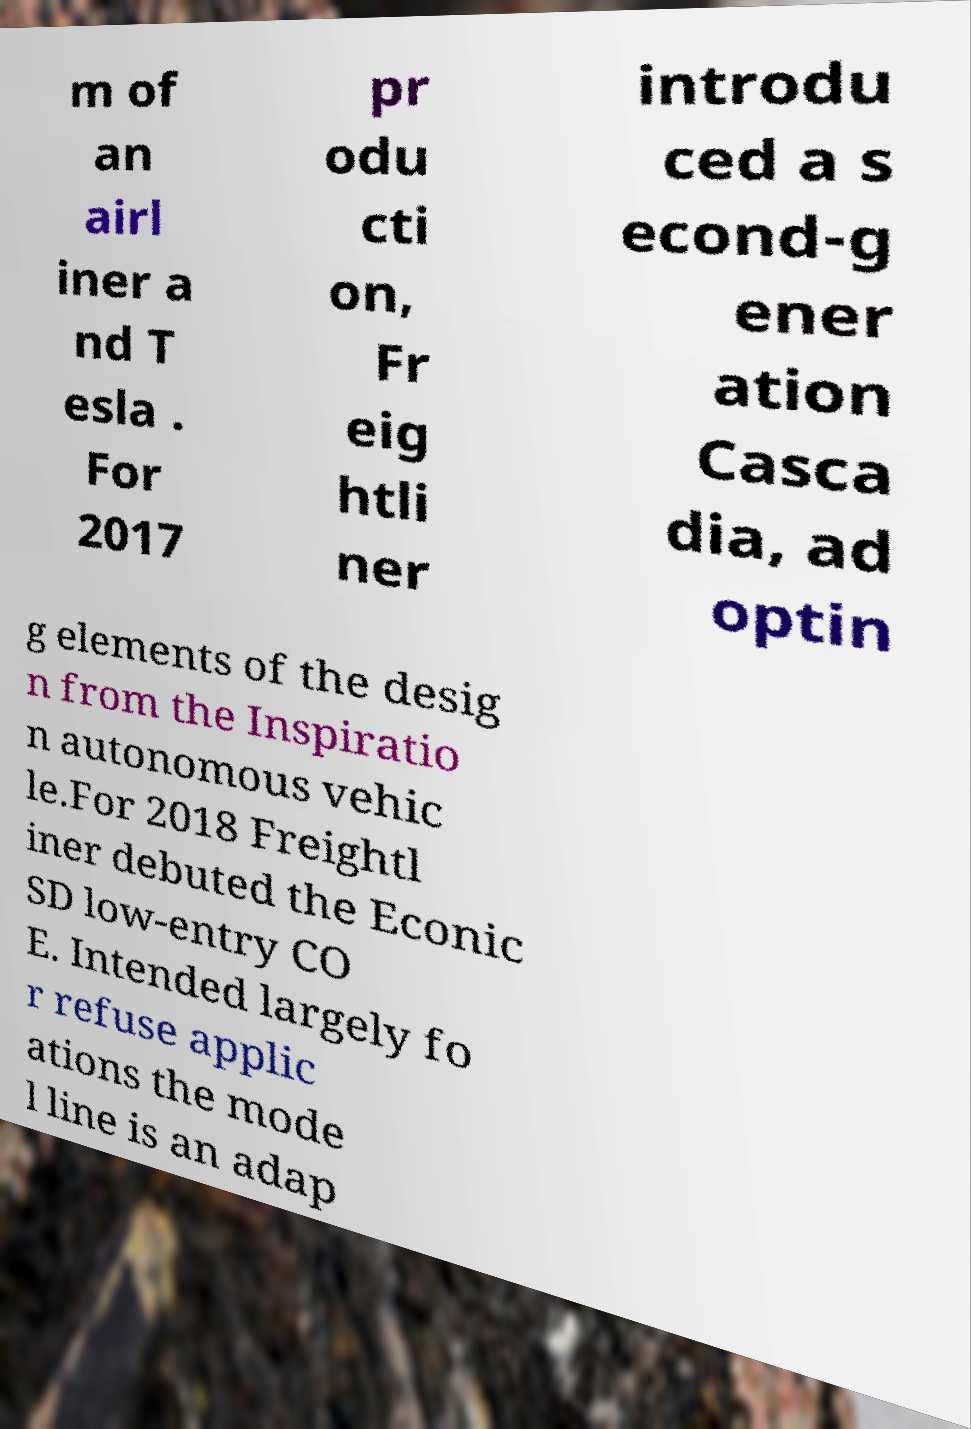Can you read and provide the text displayed in the image?This photo seems to have some interesting text. Can you extract and type it out for me? m of an airl iner a nd T esla . For 2017 pr odu cti on, Fr eig htli ner introdu ced a s econd-g ener ation Casca dia, ad optin g elements of the desig n from the Inspiratio n autonomous vehic le.For 2018 Freightl iner debuted the Econic SD low-entry CO E. Intended largely fo r refuse applic ations the mode l line is an adap 